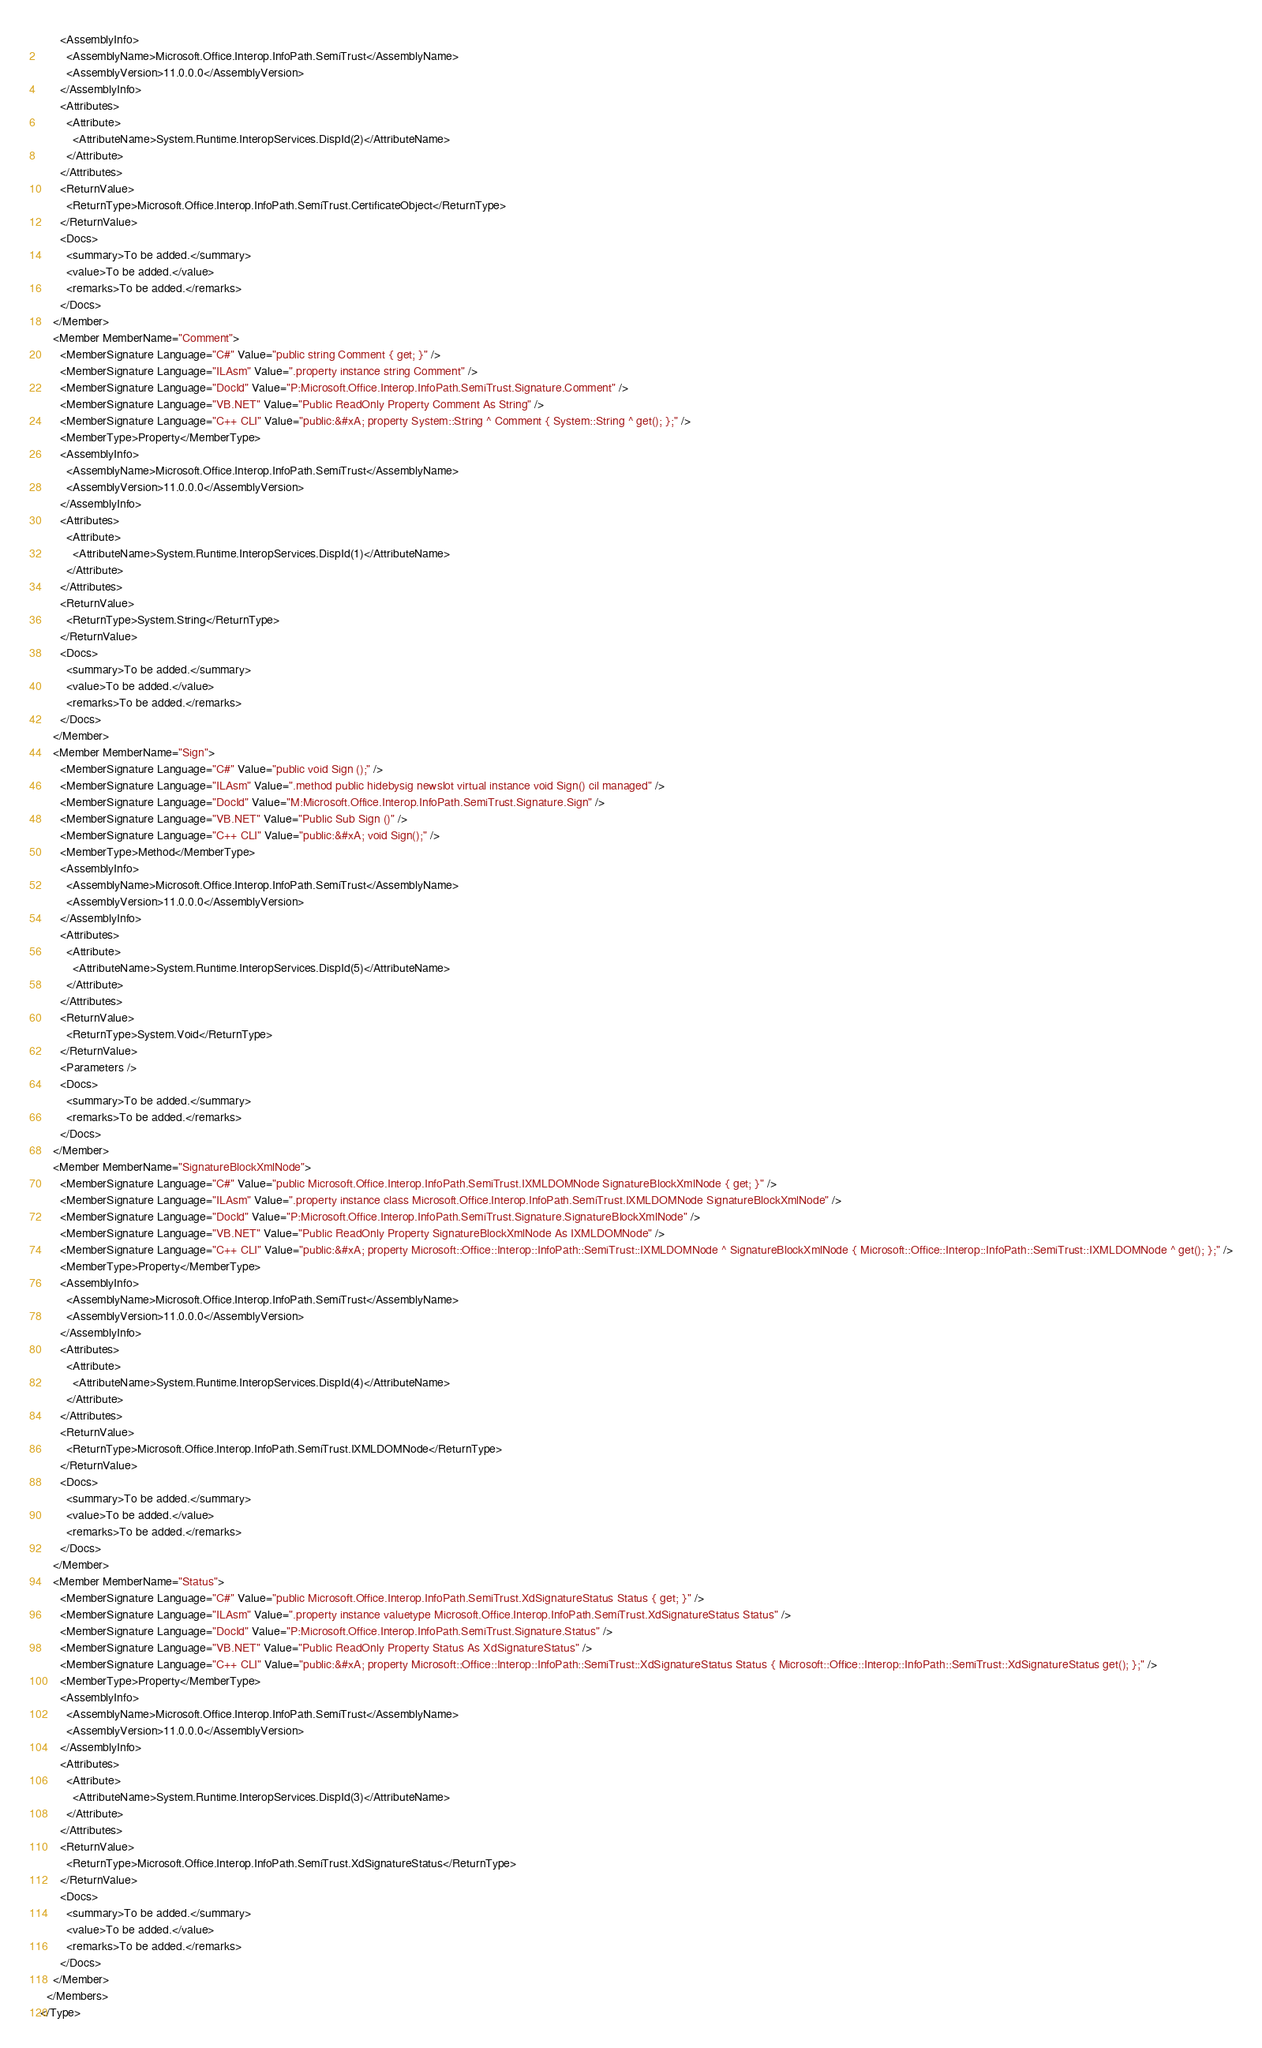Convert code to text. <code><loc_0><loc_0><loc_500><loc_500><_XML_>      <AssemblyInfo>
        <AssemblyName>Microsoft.Office.Interop.InfoPath.SemiTrust</AssemblyName>
        <AssemblyVersion>11.0.0.0</AssemblyVersion>
      </AssemblyInfo>
      <Attributes>
        <Attribute>
          <AttributeName>System.Runtime.InteropServices.DispId(2)</AttributeName>
        </Attribute>
      </Attributes>
      <ReturnValue>
        <ReturnType>Microsoft.Office.Interop.InfoPath.SemiTrust.CertificateObject</ReturnType>
      </ReturnValue>
      <Docs>
        <summary>To be added.</summary>
        <value>To be added.</value>
        <remarks>To be added.</remarks>
      </Docs>
    </Member>
    <Member MemberName="Comment">
      <MemberSignature Language="C#" Value="public string Comment { get; }" />
      <MemberSignature Language="ILAsm" Value=".property instance string Comment" />
      <MemberSignature Language="DocId" Value="P:Microsoft.Office.Interop.InfoPath.SemiTrust.Signature.Comment" />
      <MemberSignature Language="VB.NET" Value="Public ReadOnly Property Comment As String" />
      <MemberSignature Language="C++ CLI" Value="public:&#xA; property System::String ^ Comment { System::String ^ get(); };" />
      <MemberType>Property</MemberType>
      <AssemblyInfo>
        <AssemblyName>Microsoft.Office.Interop.InfoPath.SemiTrust</AssemblyName>
        <AssemblyVersion>11.0.0.0</AssemblyVersion>
      </AssemblyInfo>
      <Attributes>
        <Attribute>
          <AttributeName>System.Runtime.InteropServices.DispId(1)</AttributeName>
        </Attribute>
      </Attributes>
      <ReturnValue>
        <ReturnType>System.String</ReturnType>
      </ReturnValue>
      <Docs>
        <summary>To be added.</summary>
        <value>To be added.</value>
        <remarks>To be added.</remarks>
      </Docs>
    </Member>
    <Member MemberName="Sign">
      <MemberSignature Language="C#" Value="public void Sign ();" />
      <MemberSignature Language="ILAsm" Value=".method public hidebysig newslot virtual instance void Sign() cil managed" />
      <MemberSignature Language="DocId" Value="M:Microsoft.Office.Interop.InfoPath.SemiTrust.Signature.Sign" />
      <MemberSignature Language="VB.NET" Value="Public Sub Sign ()" />
      <MemberSignature Language="C++ CLI" Value="public:&#xA; void Sign();" />
      <MemberType>Method</MemberType>
      <AssemblyInfo>
        <AssemblyName>Microsoft.Office.Interop.InfoPath.SemiTrust</AssemblyName>
        <AssemblyVersion>11.0.0.0</AssemblyVersion>
      </AssemblyInfo>
      <Attributes>
        <Attribute>
          <AttributeName>System.Runtime.InteropServices.DispId(5)</AttributeName>
        </Attribute>
      </Attributes>
      <ReturnValue>
        <ReturnType>System.Void</ReturnType>
      </ReturnValue>
      <Parameters />
      <Docs>
        <summary>To be added.</summary>
        <remarks>To be added.</remarks>
      </Docs>
    </Member>
    <Member MemberName="SignatureBlockXmlNode">
      <MemberSignature Language="C#" Value="public Microsoft.Office.Interop.InfoPath.SemiTrust.IXMLDOMNode SignatureBlockXmlNode { get; }" />
      <MemberSignature Language="ILAsm" Value=".property instance class Microsoft.Office.Interop.InfoPath.SemiTrust.IXMLDOMNode SignatureBlockXmlNode" />
      <MemberSignature Language="DocId" Value="P:Microsoft.Office.Interop.InfoPath.SemiTrust.Signature.SignatureBlockXmlNode" />
      <MemberSignature Language="VB.NET" Value="Public ReadOnly Property SignatureBlockXmlNode As IXMLDOMNode" />
      <MemberSignature Language="C++ CLI" Value="public:&#xA; property Microsoft::Office::Interop::InfoPath::SemiTrust::IXMLDOMNode ^ SignatureBlockXmlNode { Microsoft::Office::Interop::InfoPath::SemiTrust::IXMLDOMNode ^ get(); };" />
      <MemberType>Property</MemberType>
      <AssemblyInfo>
        <AssemblyName>Microsoft.Office.Interop.InfoPath.SemiTrust</AssemblyName>
        <AssemblyVersion>11.0.0.0</AssemblyVersion>
      </AssemblyInfo>
      <Attributes>
        <Attribute>
          <AttributeName>System.Runtime.InteropServices.DispId(4)</AttributeName>
        </Attribute>
      </Attributes>
      <ReturnValue>
        <ReturnType>Microsoft.Office.Interop.InfoPath.SemiTrust.IXMLDOMNode</ReturnType>
      </ReturnValue>
      <Docs>
        <summary>To be added.</summary>
        <value>To be added.</value>
        <remarks>To be added.</remarks>
      </Docs>
    </Member>
    <Member MemberName="Status">
      <MemberSignature Language="C#" Value="public Microsoft.Office.Interop.InfoPath.SemiTrust.XdSignatureStatus Status { get; }" />
      <MemberSignature Language="ILAsm" Value=".property instance valuetype Microsoft.Office.Interop.InfoPath.SemiTrust.XdSignatureStatus Status" />
      <MemberSignature Language="DocId" Value="P:Microsoft.Office.Interop.InfoPath.SemiTrust.Signature.Status" />
      <MemberSignature Language="VB.NET" Value="Public ReadOnly Property Status As XdSignatureStatus" />
      <MemberSignature Language="C++ CLI" Value="public:&#xA; property Microsoft::Office::Interop::InfoPath::SemiTrust::XdSignatureStatus Status { Microsoft::Office::Interop::InfoPath::SemiTrust::XdSignatureStatus get(); };" />
      <MemberType>Property</MemberType>
      <AssemblyInfo>
        <AssemblyName>Microsoft.Office.Interop.InfoPath.SemiTrust</AssemblyName>
        <AssemblyVersion>11.0.0.0</AssemblyVersion>
      </AssemblyInfo>
      <Attributes>
        <Attribute>
          <AttributeName>System.Runtime.InteropServices.DispId(3)</AttributeName>
        </Attribute>
      </Attributes>
      <ReturnValue>
        <ReturnType>Microsoft.Office.Interop.InfoPath.SemiTrust.XdSignatureStatus</ReturnType>
      </ReturnValue>
      <Docs>
        <summary>To be added.</summary>
        <value>To be added.</value>
        <remarks>To be added.</remarks>
      </Docs>
    </Member>
  </Members>
</Type></code> 